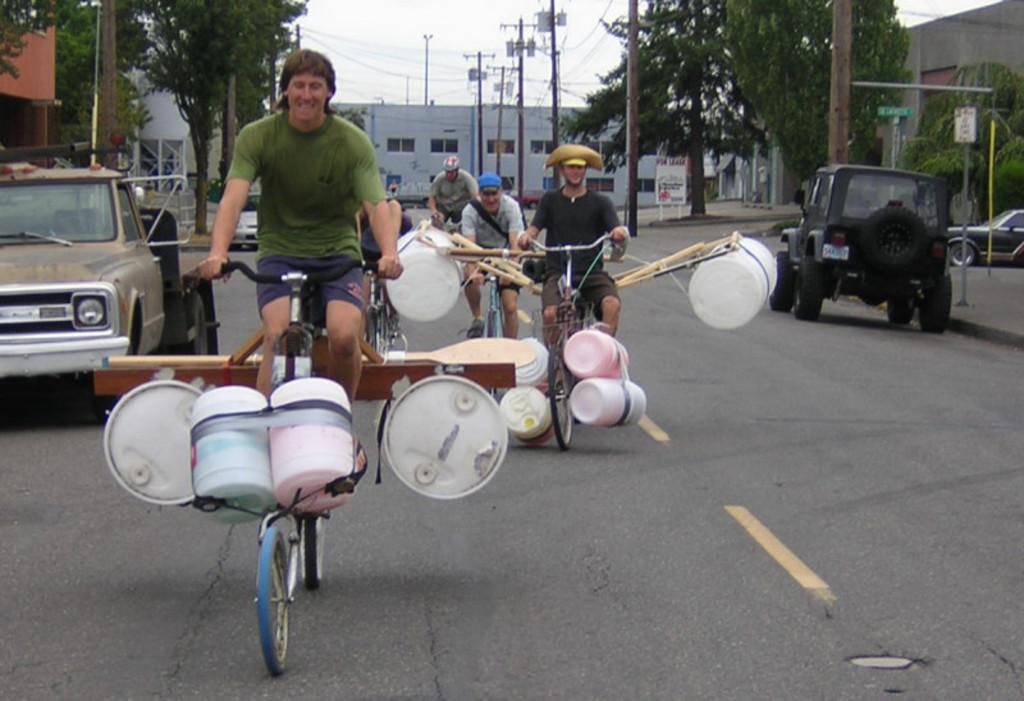Describe this image in one or two sentences. At the top we can see sky. These are buildings. These are current polls. These are trees across the road. Here we can see persons riding bicycle and we can see buckets over here. We can see vehicles on the road. These are boards. 